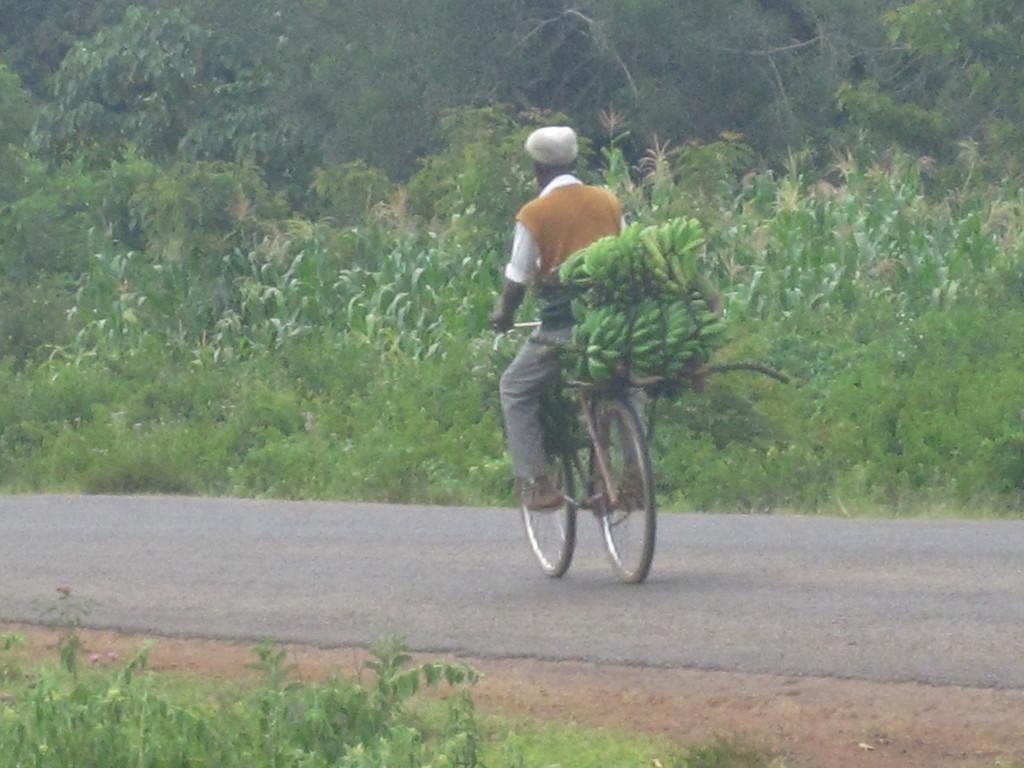Could you give a brief overview of what you see in this image? Here we can see a person riding a bicycle on road and behind him we can see bananas placed on the bicycle and we can see trees and plants present 